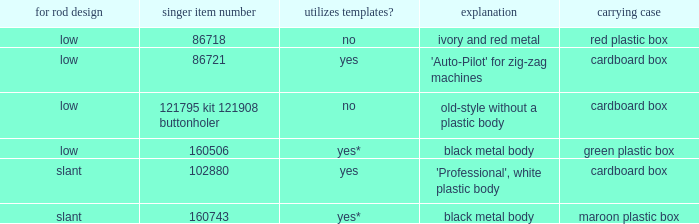What's the singer part number of the buttonholer whose storage case is a green plastic box? 160506.0. 